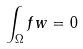<formula> <loc_0><loc_0><loc_500><loc_500>\int _ { \Omega } f w = 0</formula> 